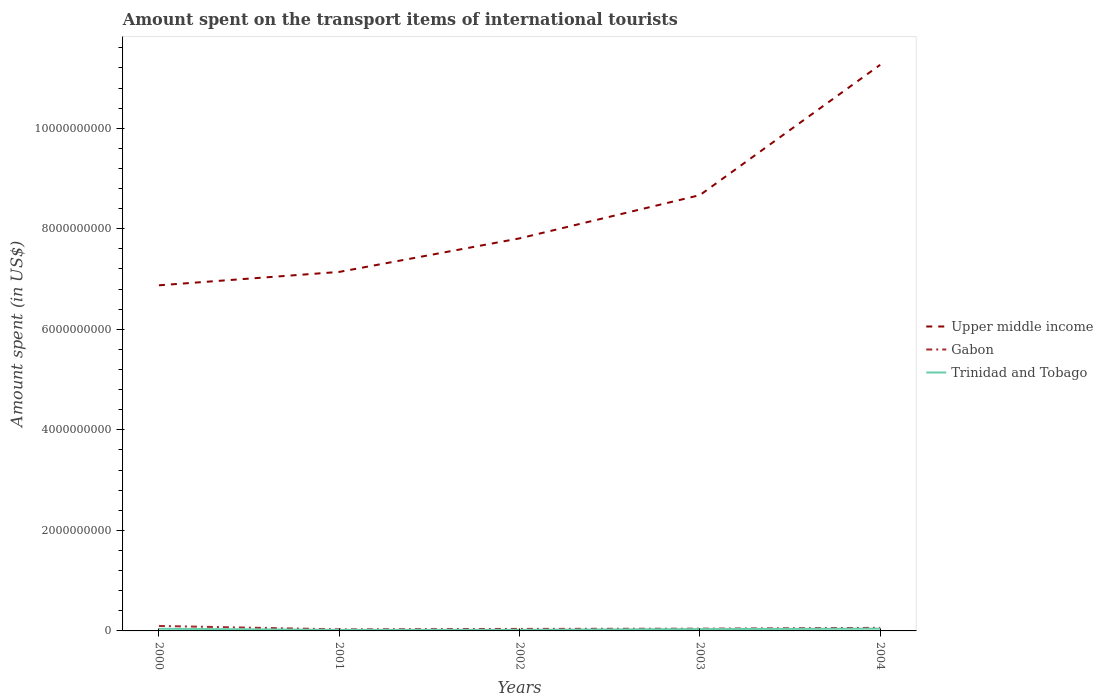Does the line corresponding to Trinidad and Tobago intersect with the line corresponding to Upper middle income?
Your answer should be very brief. No. Is the number of lines equal to the number of legend labels?
Offer a terse response. Yes. Across all years, what is the maximum amount spent on the transport items of international tourists in Trinidad and Tobago?
Ensure brevity in your answer.  2.10e+07. What is the total amount spent on the transport items of international tourists in Gabon in the graph?
Provide a succinct answer. -5.00e+06. What is the difference between the highest and the second highest amount spent on the transport items of international tourists in Gabon?
Make the answer very short. 6.80e+07. Does the graph contain grids?
Offer a terse response. No. Where does the legend appear in the graph?
Your answer should be compact. Center right. How many legend labels are there?
Your answer should be compact. 3. What is the title of the graph?
Make the answer very short. Amount spent on the transport items of international tourists. Does "High income" appear as one of the legend labels in the graph?
Provide a short and direct response. No. What is the label or title of the X-axis?
Your answer should be compact. Years. What is the label or title of the Y-axis?
Your response must be concise. Amount spent (in US$). What is the Amount spent (in US$) of Upper middle income in 2000?
Keep it short and to the point. 6.88e+09. What is the Amount spent (in US$) in Gabon in 2000?
Offer a very short reply. 9.90e+07. What is the Amount spent (in US$) of Trinidad and Tobago in 2000?
Give a very brief answer. 4.30e+07. What is the Amount spent (in US$) of Upper middle income in 2001?
Your response must be concise. 7.14e+09. What is the Amount spent (in US$) of Gabon in 2001?
Make the answer very short. 3.10e+07. What is the Amount spent (in US$) in Trinidad and Tobago in 2001?
Offer a terse response. 2.10e+07. What is the Amount spent (in US$) of Upper middle income in 2002?
Keep it short and to the point. 7.81e+09. What is the Amount spent (in US$) in Gabon in 2002?
Offer a very short reply. 4.00e+07. What is the Amount spent (in US$) in Trinidad and Tobago in 2002?
Provide a succinct answer. 2.20e+07. What is the Amount spent (in US$) of Upper middle income in 2003?
Keep it short and to the point. 8.67e+09. What is the Amount spent (in US$) of Gabon in 2003?
Make the answer very short. 4.50e+07. What is the Amount spent (in US$) of Trinidad and Tobago in 2003?
Your answer should be very brief. 3.60e+07. What is the Amount spent (in US$) of Upper middle income in 2004?
Offer a terse response. 1.13e+1. What is the Amount spent (in US$) of Gabon in 2004?
Your answer should be very brief. 6.10e+07. What is the Amount spent (in US$) in Trinidad and Tobago in 2004?
Your answer should be compact. 4.50e+07. Across all years, what is the maximum Amount spent (in US$) of Upper middle income?
Ensure brevity in your answer.  1.13e+1. Across all years, what is the maximum Amount spent (in US$) of Gabon?
Your answer should be very brief. 9.90e+07. Across all years, what is the maximum Amount spent (in US$) of Trinidad and Tobago?
Your answer should be very brief. 4.50e+07. Across all years, what is the minimum Amount spent (in US$) of Upper middle income?
Provide a short and direct response. 6.88e+09. Across all years, what is the minimum Amount spent (in US$) of Gabon?
Keep it short and to the point. 3.10e+07. Across all years, what is the minimum Amount spent (in US$) in Trinidad and Tobago?
Your answer should be very brief. 2.10e+07. What is the total Amount spent (in US$) of Upper middle income in the graph?
Make the answer very short. 4.18e+1. What is the total Amount spent (in US$) in Gabon in the graph?
Offer a very short reply. 2.76e+08. What is the total Amount spent (in US$) of Trinidad and Tobago in the graph?
Your answer should be compact. 1.67e+08. What is the difference between the Amount spent (in US$) of Upper middle income in 2000 and that in 2001?
Offer a terse response. -2.67e+08. What is the difference between the Amount spent (in US$) of Gabon in 2000 and that in 2001?
Give a very brief answer. 6.80e+07. What is the difference between the Amount spent (in US$) in Trinidad and Tobago in 2000 and that in 2001?
Offer a very short reply. 2.20e+07. What is the difference between the Amount spent (in US$) in Upper middle income in 2000 and that in 2002?
Make the answer very short. -9.34e+08. What is the difference between the Amount spent (in US$) in Gabon in 2000 and that in 2002?
Keep it short and to the point. 5.90e+07. What is the difference between the Amount spent (in US$) of Trinidad and Tobago in 2000 and that in 2002?
Offer a very short reply. 2.10e+07. What is the difference between the Amount spent (in US$) of Upper middle income in 2000 and that in 2003?
Give a very brief answer. -1.79e+09. What is the difference between the Amount spent (in US$) of Gabon in 2000 and that in 2003?
Provide a short and direct response. 5.40e+07. What is the difference between the Amount spent (in US$) of Upper middle income in 2000 and that in 2004?
Give a very brief answer. -4.39e+09. What is the difference between the Amount spent (in US$) of Gabon in 2000 and that in 2004?
Offer a very short reply. 3.80e+07. What is the difference between the Amount spent (in US$) of Trinidad and Tobago in 2000 and that in 2004?
Ensure brevity in your answer.  -2.00e+06. What is the difference between the Amount spent (in US$) in Upper middle income in 2001 and that in 2002?
Give a very brief answer. -6.67e+08. What is the difference between the Amount spent (in US$) of Gabon in 2001 and that in 2002?
Keep it short and to the point. -9.00e+06. What is the difference between the Amount spent (in US$) of Trinidad and Tobago in 2001 and that in 2002?
Keep it short and to the point. -1.00e+06. What is the difference between the Amount spent (in US$) of Upper middle income in 2001 and that in 2003?
Your response must be concise. -1.53e+09. What is the difference between the Amount spent (in US$) in Gabon in 2001 and that in 2003?
Make the answer very short. -1.40e+07. What is the difference between the Amount spent (in US$) of Trinidad and Tobago in 2001 and that in 2003?
Your answer should be very brief. -1.50e+07. What is the difference between the Amount spent (in US$) in Upper middle income in 2001 and that in 2004?
Provide a succinct answer. -4.12e+09. What is the difference between the Amount spent (in US$) of Gabon in 2001 and that in 2004?
Provide a short and direct response. -3.00e+07. What is the difference between the Amount spent (in US$) in Trinidad and Tobago in 2001 and that in 2004?
Offer a very short reply. -2.40e+07. What is the difference between the Amount spent (in US$) of Upper middle income in 2002 and that in 2003?
Your response must be concise. -8.60e+08. What is the difference between the Amount spent (in US$) of Gabon in 2002 and that in 2003?
Keep it short and to the point. -5.00e+06. What is the difference between the Amount spent (in US$) in Trinidad and Tobago in 2002 and that in 2003?
Make the answer very short. -1.40e+07. What is the difference between the Amount spent (in US$) of Upper middle income in 2002 and that in 2004?
Provide a succinct answer. -3.45e+09. What is the difference between the Amount spent (in US$) in Gabon in 2002 and that in 2004?
Keep it short and to the point. -2.10e+07. What is the difference between the Amount spent (in US$) in Trinidad and Tobago in 2002 and that in 2004?
Your answer should be very brief. -2.30e+07. What is the difference between the Amount spent (in US$) of Upper middle income in 2003 and that in 2004?
Offer a terse response. -2.59e+09. What is the difference between the Amount spent (in US$) of Gabon in 2003 and that in 2004?
Your answer should be compact. -1.60e+07. What is the difference between the Amount spent (in US$) in Trinidad and Tobago in 2003 and that in 2004?
Your answer should be compact. -9.00e+06. What is the difference between the Amount spent (in US$) of Upper middle income in 2000 and the Amount spent (in US$) of Gabon in 2001?
Give a very brief answer. 6.84e+09. What is the difference between the Amount spent (in US$) of Upper middle income in 2000 and the Amount spent (in US$) of Trinidad and Tobago in 2001?
Provide a succinct answer. 6.85e+09. What is the difference between the Amount spent (in US$) in Gabon in 2000 and the Amount spent (in US$) in Trinidad and Tobago in 2001?
Give a very brief answer. 7.80e+07. What is the difference between the Amount spent (in US$) in Upper middle income in 2000 and the Amount spent (in US$) in Gabon in 2002?
Ensure brevity in your answer.  6.84e+09. What is the difference between the Amount spent (in US$) in Upper middle income in 2000 and the Amount spent (in US$) in Trinidad and Tobago in 2002?
Your answer should be compact. 6.85e+09. What is the difference between the Amount spent (in US$) in Gabon in 2000 and the Amount spent (in US$) in Trinidad and Tobago in 2002?
Your answer should be very brief. 7.70e+07. What is the difference between the Amount spent (in US$) in Upper middle income in 2000 and the Amount spent (in US$) in Gabon in 2003?
Provide a succinct answer. 6.83e+09. What is the difference between the Amount spent (in US$) of Upper middle income in 2000 and the Amount spent (in US$) of Trinidad and Tobago in 2003?
Your answer should be compact. 6.84e+09. What is the difference between the Amount spent (in US$) in Gabon in 2000 and the Amount spent (in US$) in Trinidad and Tobago in 2003?
Your answer should be compact. 6.30e+07. What is the difference between the Amount spent (in US$) of Upper middle income in 2000 and the Amount spent (in US$) of Gabon in 2004?
Keep it short and to the point. 6.81e+09. What is the difference between the Amount spent (in US$) in Upper middle income in 2000 and the Amount spent (in US$) in Trinidad and Tobago in 2004?
Provide a short and direct response. 6.83e+09. What is the difference between the Amount spent (in US$) of Gabon in 2000 and the Amount spent (in US$) of Trinidad and Tobago in 2004?
Offer a terse response. 5.40e+07. What is the difference between the Amount spent (in US$) of Upper middle income in 2001 and the Amount spent (in US$) of Gabon in 2002?
Give a very brief answer. 7.10e+09. What is the difference between the Amount spent (in US$) in Upper middle income in 2001 and the Amount spent (in US$) in Trinidad and Tobago in 2002?
Your answer should be very brief. 7.12e+09. What is the difference between the Amount spent (in US$) of Gabon in 2001 and the Amount spent (in US$) of Trinidad and Tobago in 2002?
Your answer should be compact. 9.00e+06. What is the difference between the Amount spent (in US$) in Upper middle income in 2001 and the Amount spent (in US$) in Gabon in 2003?
Offer a terse response. 7.10e+09. What is the difference between the Amount spent (in US$) in Upper middle income in 2001 and the Amount spent (in US$) in Trinidad and Tobago in 2003?
Your answer should be very brief. 7.11e+09. What is the difference between the Amount spent (in US$) in Gabon in 2001 and the Amount spent (in US$) in Trinidad and Tobago in 2003?
Provide a short and direct response. -5.00e+06. What is the difference between the Amount spent (in US$) of Upper middle income in 2001 and the Amount spent (in US$) of Gabon in 2004?
Provide a short and direct response. 7.08e+09. What is the difference between the Amount spent (in US$) of Upper middle income in 2001 and the Amount spent (in US$) of Trinidad and Tobago in 2004?
Provide a succinct answer. 7.10e+09. What is the difference between the Amount spent (in US$) of Gabon in 2001 and the Amount spent (in US$) of Trinidad and Tobago in 2004?
Keep it short and to the point. -1.40e+07. What is the difference between the Amount spent (in US$) of Upper middle income in 2002 and the Amount spent (in US$) of Gabon in 2003?
Offer a very short reply. 7.76e+09. What is the difference between the Amount spent (in US$) of Upper middle income in 2002 and the Amount spent (in US$) of Trinidad and Tobago in 2003?
Provide a succinct answer. 7.77e+09. What is the difference between the Amount spent (in US$) of Upper middle income in 2002 and the Amount spent (in US$) of Gabon in 2004?
Ensure brevity in your answer.  7.75e+09. What is the difference between the Amount spent (in US$) of Upper middle income in 2002 and the Amount spent (in US$) of Trinidad and Tobago in 2004?
Your answer should be compact. 7.76e+09. What is the difference between the Amount spent (in US$) in Gabon in 2002 and the Amount spent (in US$) in Trinidad and Tobago in 2004?
Make the answer very short. -5.00e+06. What is the difference between the Amount spent (in US$) of Upper middle income in 2003 and the Amount spent (in US$) of Gabon in 2004?
Ensure brevity in your answer.  8.61e+09. What is the difference between the Amount spent (in US$) in Upper middle income in 2003 and the Amount spent (in US$) in Trinidad and Tobago in 2004?
Keep it short and to the point. 8.62e+09. What is the average Amount spent (in US$) of Upper middle income per year?
Make the answer very short. 8.35e+09. What is the average Amount spent (in US$) in Gabon per year?
Provide a succinct answer. 5.52e+07. What is the average Amount spent (in US$) of Trinidad and Tobago per year?
Offer a very short reply. 3.34e+07. In the year 2000, what is the difference between the Amount spent (in US$) of Upper middle income and Amount spent (in US$) of Gabon?
Keep it short and to the point. 6.78e+09. In the year 2000, what is the difference between the Amount spent (in US$) of Upper middle income and Amount spent (in US$) of Trinidad and Tobago?
Your response must be concise. 6.83e+09. In the year 2000, what is the difference between the Amount spent (in US$) in Gabon and Amount spent (in US$) in Trinidad and Tobago?
Keep it short and to the point. 5.60e+07. In the year 2001, what is the difference between the Amount spent (in US$) of Upper middle income and Amount spent (in US$) of Gabon?
Provide a short and direct response. 7.11e+09. In the year 2001, what is the difference between the Amount spent (in US$) in Upper middle income and Amount spent (in US$) in Trinidad and Tobago?
Offer a very short reply. 7.12e+09. In the year 2002, what is the difference between the Amount spent (in US$) of Upper middle income and Amount spent (in US$) of Gabon?
Offer a very short reply. 7.77e+09. In the year 2002, what is the difference between the Amount spent (in US$) of Upper middle income and Amount spent (in US$) of Trinidad and Tobago?
Your answer should be very brief. 7.79e+09. In the year 2002, what is the difference between the Amount spent (in US$) in Gabon and Amount spent (in US$) in Trinidad and Tobago?
Keep it short and to the point. 1.80e+07. In the year 2003, what is the difference between the Amount spent (in US$) in Upper middle income and Amount spent (in US$) in Gabon?
Make the answer very short. 8.62e+09. In the year 2003, what is the difference between the Amount spent (in US$) of Upper middle income and Amount spent (in US$) of Trinidad and Tobago?
Keep it short and to the point. 8.63e+09. In the year 2003, what is the difference between the Amount spent (in US$) of Gabon and Amount spent (in US$) of Trinidad and Tobago?
Make the answer very short. 9.00e+06. In the year 2004, what is the difference between the Amount spent (in US$) of Upper middle income and Amount spent (in US$) of Gabon?
Keep it short and to the point. 1.12e+1. In the year 2004, what is the difference between the Amount spent (in US$) of Upper middle income and Amount spent (in US$) of Trinidad and Tobago?
Make the answer very short. 1.12e+1. In the year 2004, what is the difference between the Amount spent (in US$) in Gabon and Amount spent (in US$) in Trinidad and Tobago?
Your answer should be compact. 1.60e+07. What is the ratio of the Amount spent (in US$) of Upper middle income in 2000 to that in 2001?
Offer a very short reply. 0.96. What is the ratio of the Amount spent (in US$) of Gabon in 2000 to that in 2001?
Your response must be concise. 3.19. What is the ratio of the Amount spent (in US$) of Trinidad and Tobago in 2000 to that in 2001?
Give a very brief answer. 2.05. What is the ratio of the Amount spent (in US$) of Upper middle income in 2000 to that in 2002?
Ensure brevity in your answer.  0.88. What is the ratio of the Amount spent (in US$) of Gabon in 2000 to that in 2002?
Give a very brief answer. 2.48. What is the ratio of the Amount spent (in US$) in Trinidad and Tobago in 2000 to that in 2002?
Ensure brevity in your answer.  1.95. What is the ratio of the Amount spent (in US$) of Upper middle income in 2000 to that in 2003?
Your answer should be compact. 0.79. What is the ratio of the Amount spent (in US$) in Gabon in 2000 to that in 2003?
Keep it short and to the point. 2.2. What is the ratio of the Amount spent (in US$) of Trinidad and Tobago in 2000 to that in 2003?
Provide a succinct answer. 1.19. What is the ratio of the Amount spent (in US$) of Upper middle income in 2000 to that in 2004?
Your answer should be very brief. 0.61. What is the ratio of the Amount spent (in US$) in Gabon in 2000 to that in 2004?
Keep it short and to the point. 1.62. What is the ratio of the Amount spent (in US$) of Trinidad and Tobago in 2000 to that in 2004?
Your answer should be compact. 0.96. What is the ratio of the Amount spent (in US$) in Upper middle income in 2001 to that in 2002?
Provide a short and direct response. 0.91. What is the ratio of the Amount spent (in US$) of Gabon in 2001 to that in 2002?
Keep it short and to the point. 0.78. What is the ratio of the Amount spent (in US$) in Trinidad and Tobago in 2001 to that in 2002?
Your response must be concise. 0.95. What is the ratio of the Amount spent (in US$) in Upper middle income in 2001 to that in 2003?
Provide a succinct answer. 0.82. What is the ratio of the Amount spent (in US$) of Gabon in 2001 to that in 2003?
Provide a succinct answer. 0.69. What is the ratio of the Amount spent (in US$) in Trinidad and Tobago in 2001 to that in 2003?
Your answer should be very brief. 0.58. What is the ratio of the Amount spent (in US$) in Upper middle income in 2001 to that in 2004?
Ensure brevity in your answer.  0.63. What is the ratio of the Amount spent (in US$) in Gabon in 2001 to that in 2004?
Give a very brief answer. 0.51. What is the ratio of the Amount spent (in US$) in Trinidad and Tobago in 2001 to that in 2004?
Offer a terse response. 0.47. What is the ratio of the Amount spent (in US$) in Upper middle income in 2002 to that in 2003?
Ensure brevity in your answer.  0.9. What is the ratio of the Amount spent (in US$) in Trinidad and Tobago in 2002 to that in 2003?
Your response must be concise. 0.61. What is the ratio of the Amount spent (in US$) in Upper middle income in 2002 to that in 2004?
Give a very brief answer. 0.69. What is the ratio of the Amount spent (in US$) of Gabon in 2002 to that in 2004?
Ensure brevity in your answer.  0.66. What is the ratio of the Amount spent (in US$) in Trinidad and Tobago in 2002 to that in 2004?
Keep it short and to the point. 0.49. What is the ratio of the Amount spent (in US$) in Upper middle income in 2003 to that in 2004?
Keep it short and to the point. 0.77. What is the ratio of the Amount spent (in US$) in Gabon in 2003 to that in 2004?
Provide a succinct answer. 0.74. What is the difference between the highest and the second highest Amount spent (in US$) of Upper middle income?
Give a very brief answer. 2.59e+09. What is the difference between the highest and the second highest Amount spent (in US$) of Gabon?
Keep it short and to the point. 3.80e+07. What is the difference between the highest and the lowest Amount spent (in US$) of Upper middle income?
Ensure brevity in your answer.  4.39e+09. What is the difference between the highest and the lowest Amount spent (in US$) of Gabon?
Give a very brief answer. 6.80e+07. What is the difference between the highest and the lowest Amount spent (in US$) in Trinidad and Tobago?
Keep it short and to the point. 2.40e+07. 